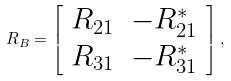Convert formula to latex. <formula><loc_0><loc_0><loc_500><loc_500>R _ { B } = \left [ \begin{array} { c c } R _ { 2 1 } & - R _ { 2 1 } ^ { * } \\ R _ { 3 1 } & - R _ { 3 1 } ^ { * } \end{array} \right ] ,</formula> 